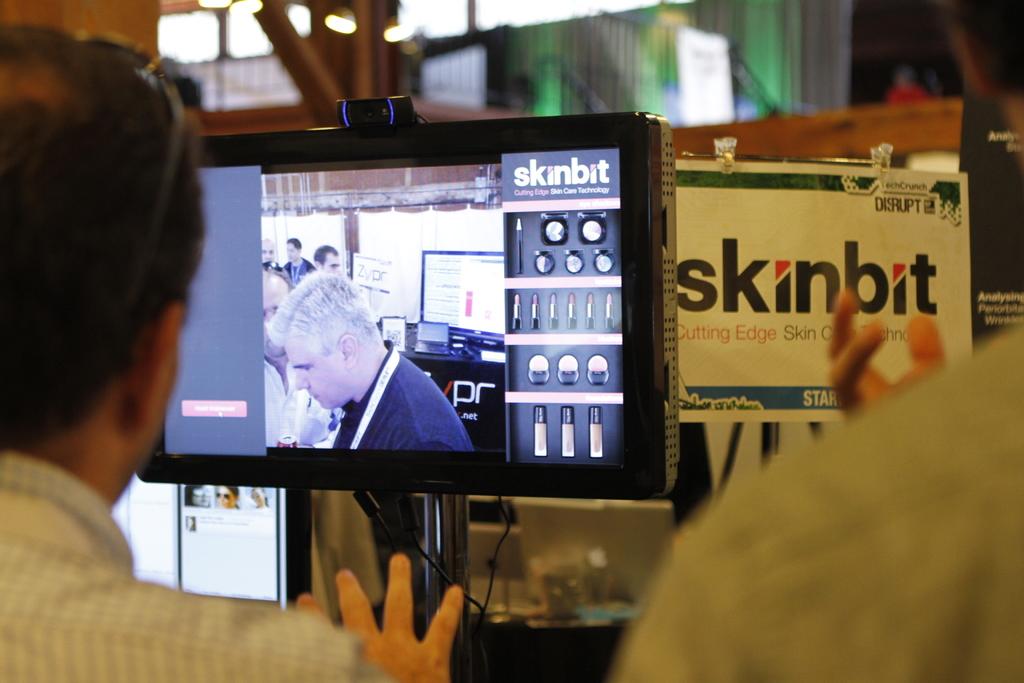What is on the sign to the right of the television?
Give a very brief answer. Skinbit. What is skinbit for or about?
Your response must be concise. Cutting edge skin care technology. 